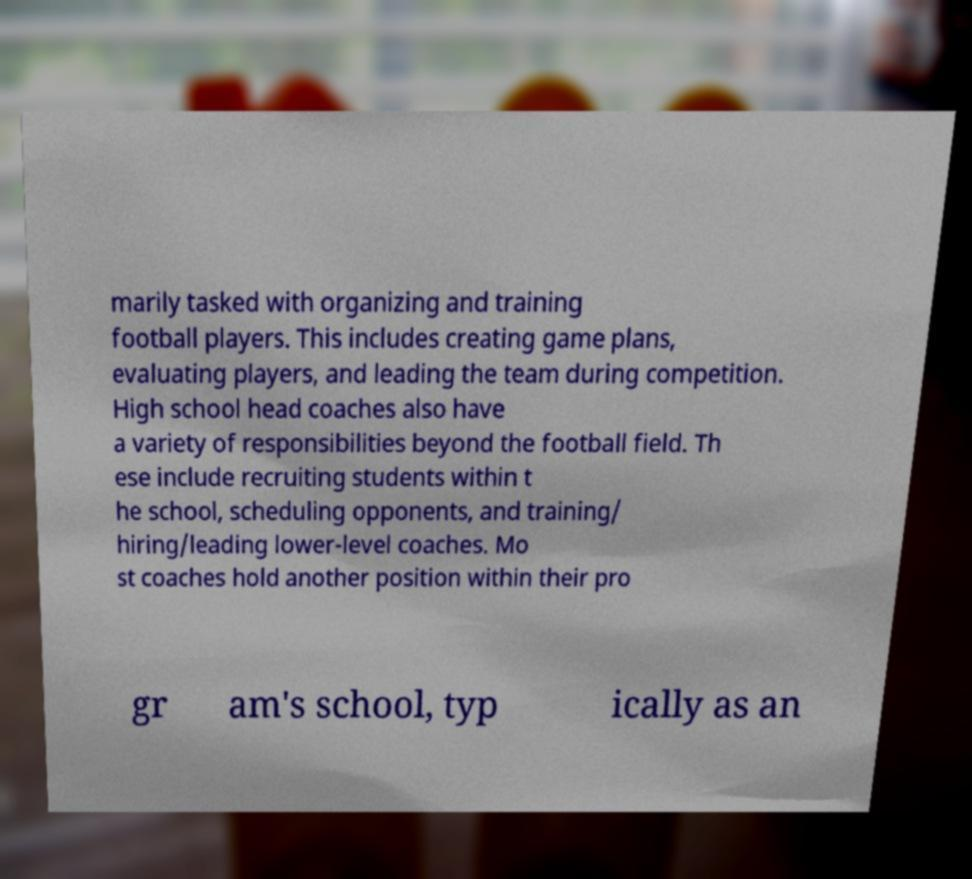Please identify and transcribe the text found in this image. marily tasked with organizing and training football players. This includes creating game plans, evaluating players, and leading the team during competition. High school head coaches also have a variety of responsibilities beyond the football field. Th ese include recruiting students within t he school, scheduling opponents, and training/ hiring/leading lower-level coaches. Mo st coaches hold another position within their pro gr am's school, typ ically as an 